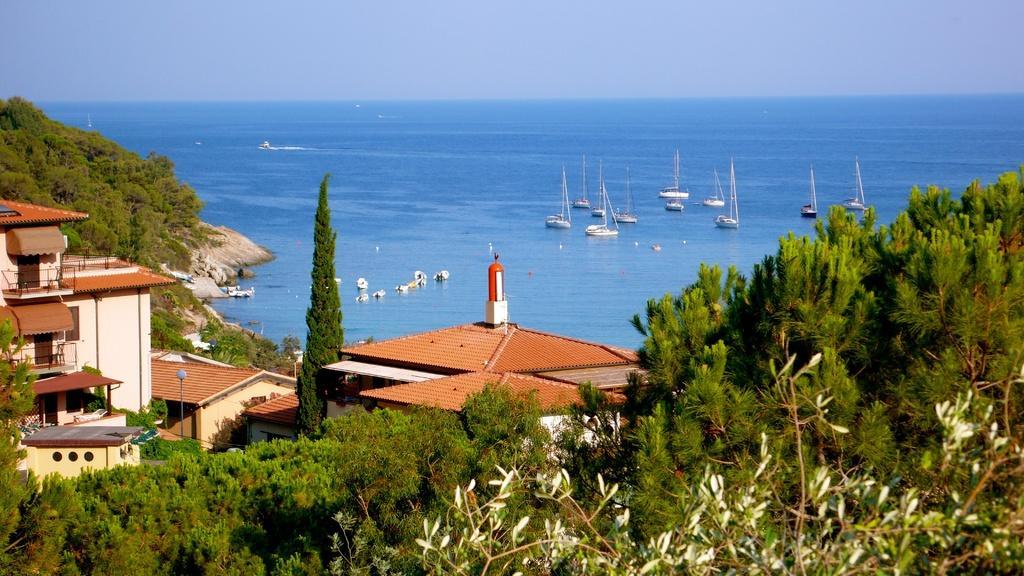Please provide a concise description of this image. This image is clicked from a top view. There are buildings in the image. At the bottom there are trees. To the left there is a mountain. There are trees on the mountain. In the background there is the water. There are boats on the water. At the top there is the sky. 